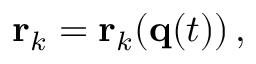<formula> <loc_0><loc_0><loc_500><loc_500>r _ { k } = r _ { k } ( q ( t ) ) \, ,</formula> 